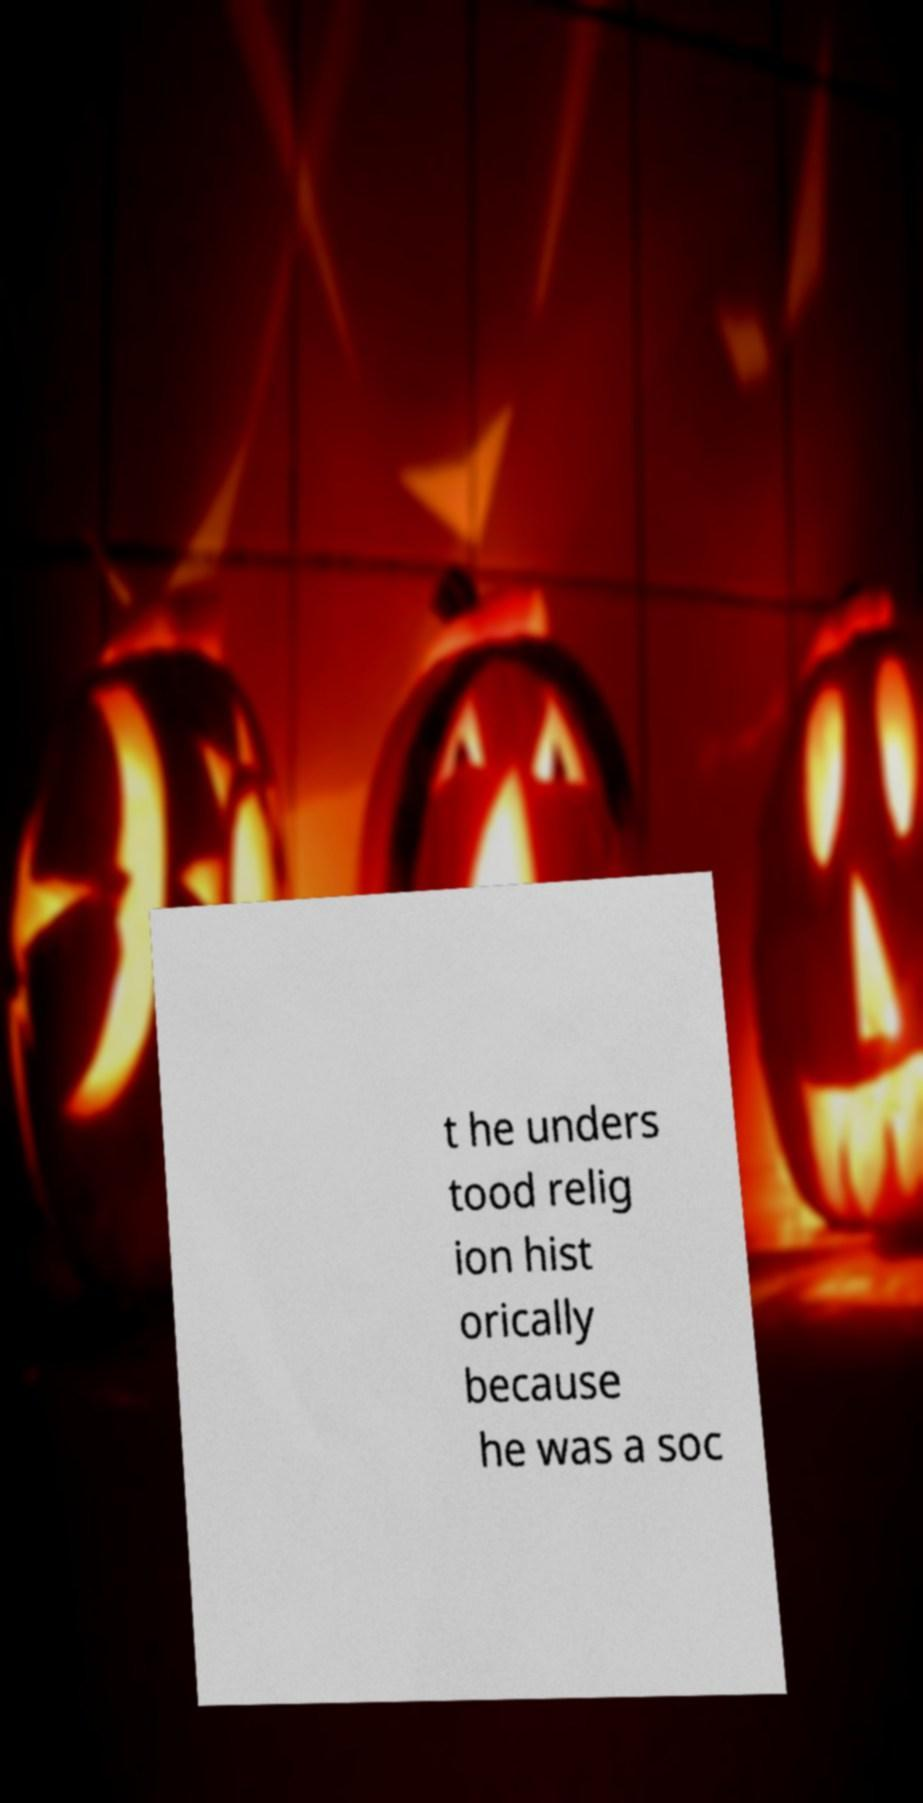I need the written content from this picture converted into text. Can you do that? t he unders tood relig ion hist orically because he was a soc 